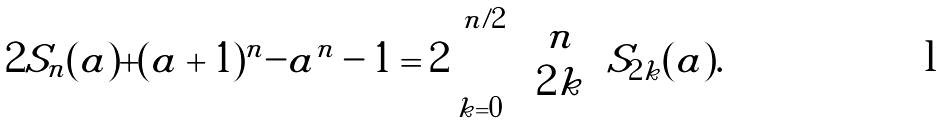<formula> <loc_0><loc_0><loc_500><loc_500>2 S _ { n } ( a ) + ( a + 1 ) ^ { n } - a ^ { n } - 1 = 2 \sum _ { k = 0 } ^ { n / 2 } \binom { n } { 2 k } S _ { 2 k } ( a ) .</formula> 